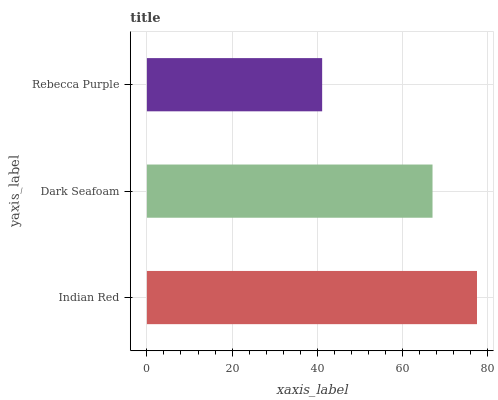Is Rebecca Purple the minimum?
Answer yes or no. Yes. Is Indian Red the maximum?
Answer yes or no. Yes. Is Dark Seafoam the minimum?
Answer yes or no. No. Is Dark Seafoam the maximum?
Answer yes or no. No. Is Indian Red greater than Dark Seafoam?
Answer yes or no. Yes. Is Dark Seafoam less than Indian Red?
Answer yes or no. Yes. Is Dark Seafoam greater than Indian Red?
Answer yes or no. No. Is Indian Red less than Dark Seafoam?
Answer yes or no. No. Is Dark Seafoam the high median?
Answer yes or no. Yes. Is Dark Seafoam the low median?
Answer yes or no. Yes. Is Indian Red the high median?
Answer yes or no. No. Is Rebecca Purple the low median?
Answer yes or no. No. 